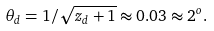Convert formula to latex. <formula><loc_0><loc_0><loc_500><loc_500>\theta _ { d } = 1 / \sqrt { z _ { d } + 1 } \approx 0 . 0 3 \approx 2 ^ { o } .</formula> 